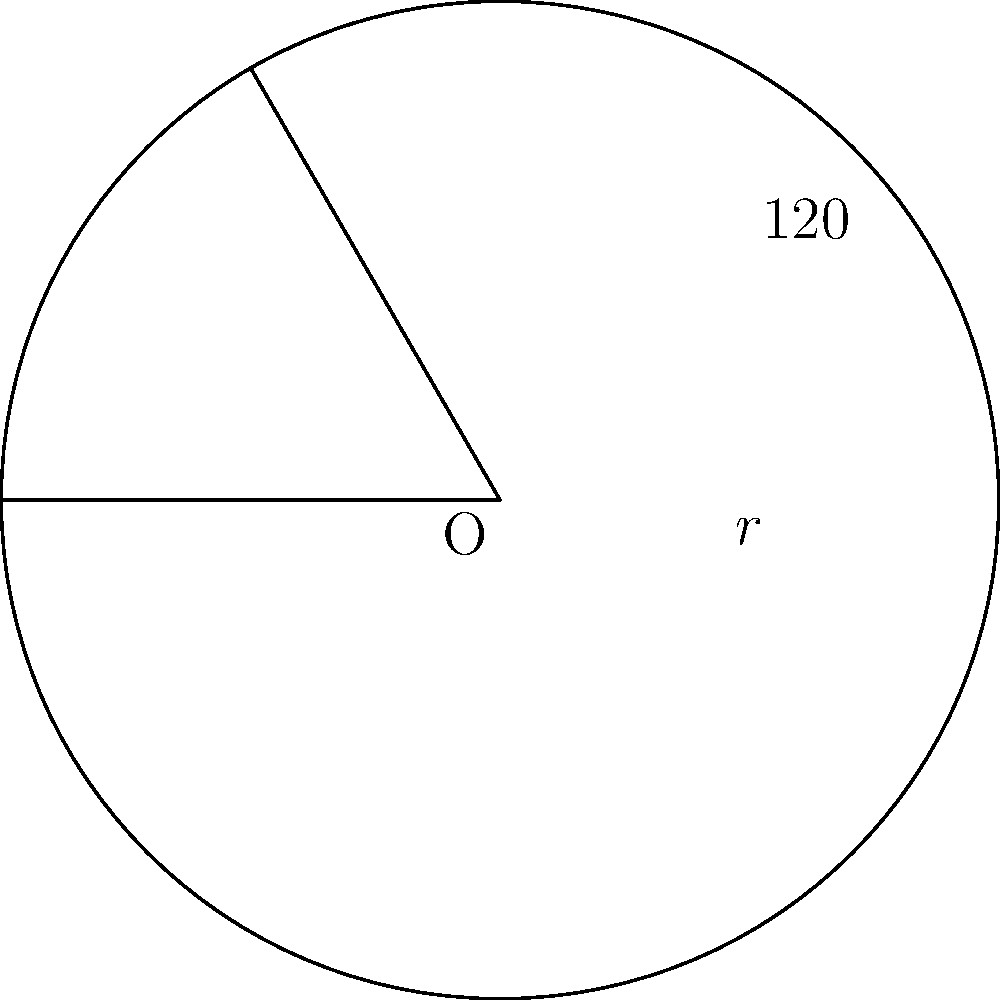At a rock concert, the stage is set up in a circular shape with a radius of 30 meters. The sound equipment covers a sector of this circle with a central angle of 120°. If you're standing at the edge of this sector, how many square meters of the stage area are blasting music directly at you? Round your answer to the nearest whole number. To solve this problem, we need to calculate the area of a circular sector. Here's how we do it step-by-step:

1) The formula for the area of a circular sector is:

   $A = \frac{\theta}{360°} \pi r^2$

   Where $\theta$ is the central angle in degrees, and $r$ is the radius.

2) We're given:
   $\theta = 120°$
   $r = 30$ meters

3) Let's substitute these values into our formula:

   $A = \frac{120°}{360°} \pi (30\text{ m})^2$

4) Simplify:
   $A = \frac{1}{3} \pi (900\text{ m}^2)$

5) Calculate:
   $A = 300\pi \text{ m}^2$

6) Use 3.14159 for $\pi$ and calculate:
   $A = 300 * 3.14159 \text{ m}^2 = 942.477 \text{ m}^2$

7) Rounding to the nearest whole number:
   $A \approx 942 \text{ m}^2$
Answer: 942 m² 